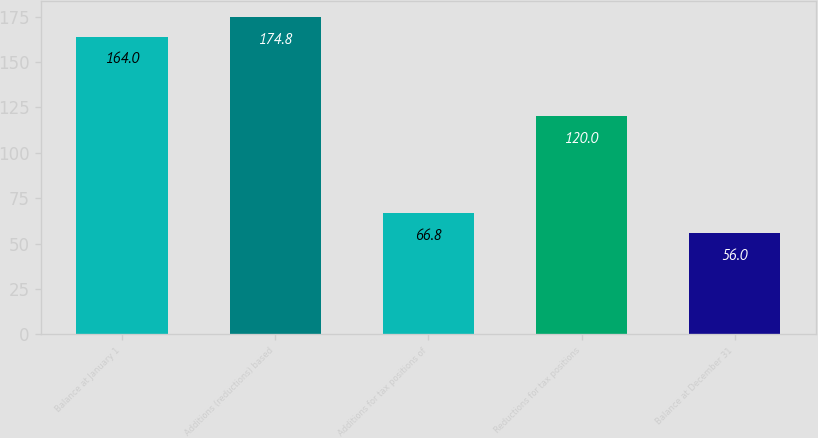Convert chart to OTSL. <chart><loc_0><loc_0><loc_500><loc_500><bar_chart><fcel>Balance at January 1<fcel>Additions (reductions) based<fcel>Additions for tax positions of<fcel>Reductions for tax positions<fcel>Balance at December 31<nl><fcel>164<fcel>174.8<fcel>66.8<fcel>120<fcel>56<nl></chart> 